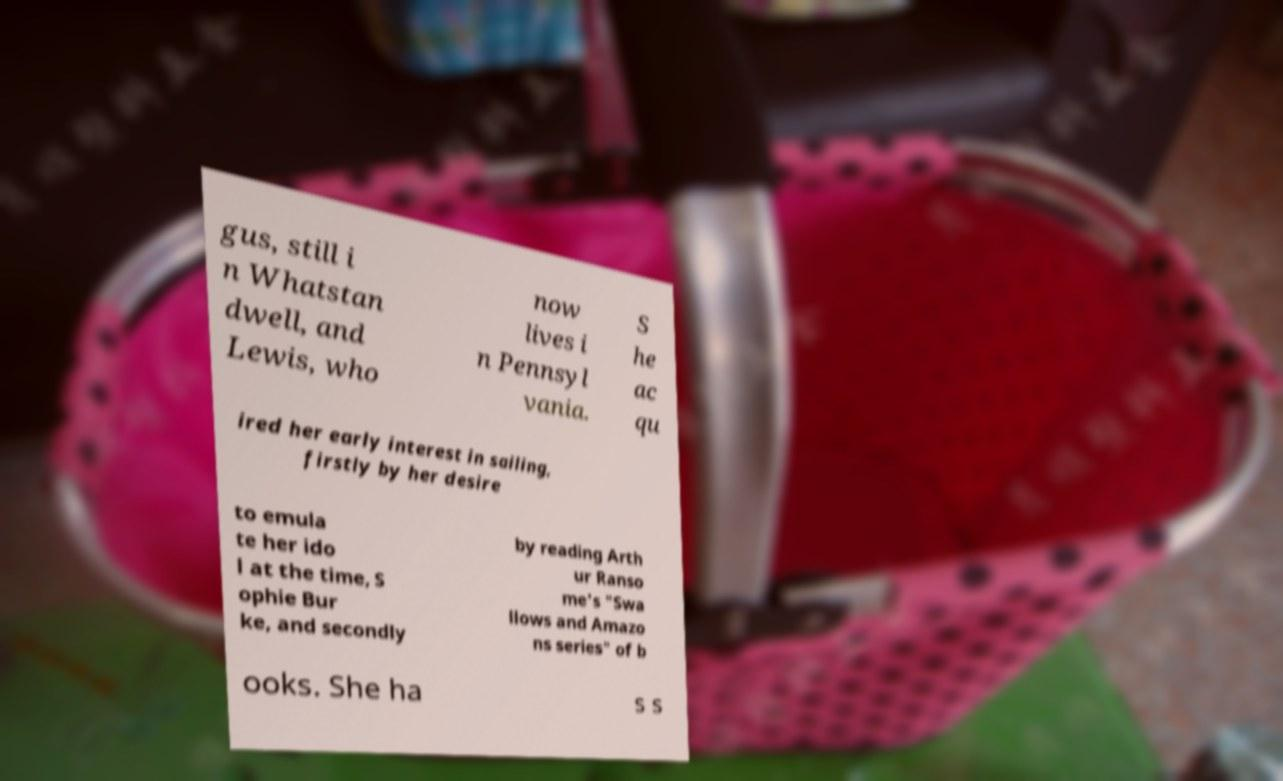Can you read and provide the text displayed in the image?This photo seems to have some interesting text. Can you extract and type it out for me? gus, still i n Whatstan dwell, and Lewis, who now lives i n Pennsyl vania. S he ac qu ired her early interest in sailing, firstly by her desire to emula te her ido l at the time, S ophie Bur ke, and secondly by reading Arth ur Ranso me's "Swa llows and Amazo ns series" of b ooks. She ha s s 